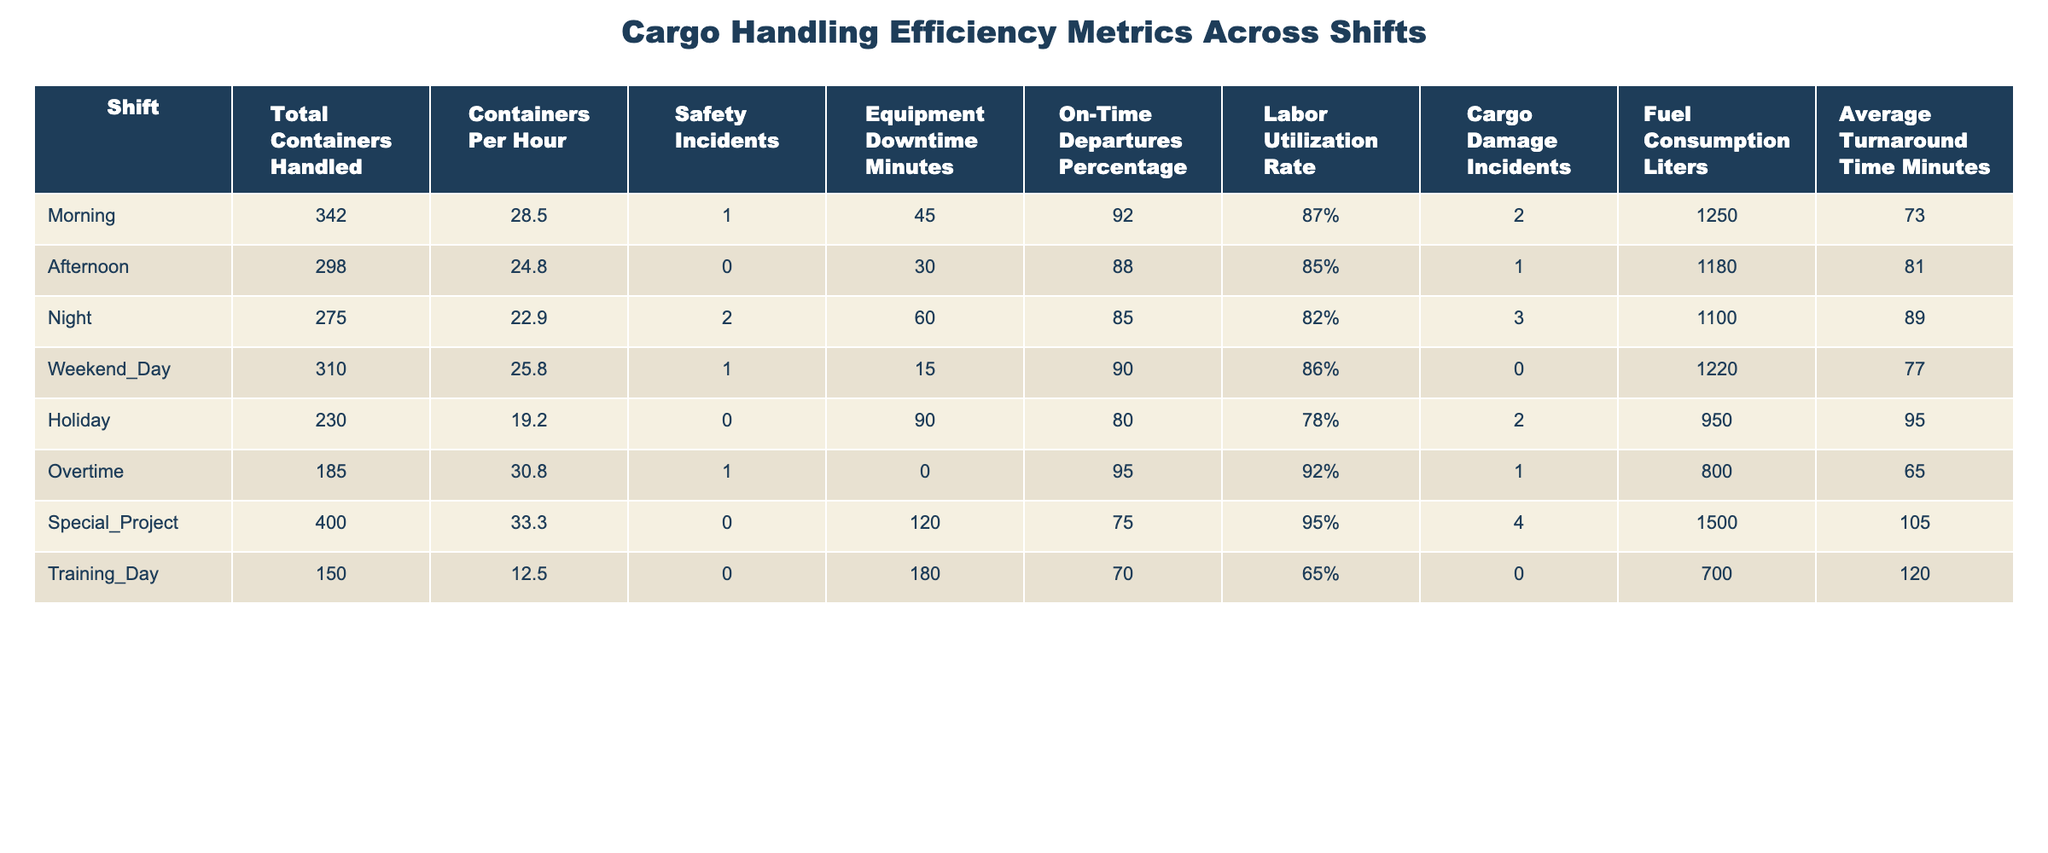What shift had the highest number of total containers handled? The total containers handled are as follows: Morning (342), Afternoon (298), Night (275), Weekend Day (310), Holiday (230), Overtime (185), Special Project (400), Training Day (150). The highest is 400, which corresponds to the Special Project shift.
Answer: Special Project What is the average containers per hour across all shifts? The containers per hour for each shift are: Morning (28.5), Afternoon (24.8), Night (22.9), Weekend Day (25.8), Holiday (19.2), Overtime (30.8), Special Project (33.3), Training Day (12.5). Adding these gives 28.5 + 24.8 + 22.9 + 25.8 + 19.2 + 30.8 + 33.3 + 12.5 =  197.8. Since there are 8 shifts, the average is 197.8 / 8 = 24.725.
Answer: 24.725 How many shifts had zero safety incidents? Referencing the data: there are 5 shifts listed as having 0 safety incidents: Afternoon, Holiday, Overtime, Special Project, and Training Day. Therefore, the total is 5 shifts.
Answer: 5 Which shift had the longest average turnaround time? The average turnaround times are: Morning (73), Afternoon (81), Night (89), Weekend Day (77), Holiday (95), Overtime (65), Special Project (105), and Training Day (120). The highest is 120, corresponding to the Training Day shift.
Answer: Training Day What percentage of on-time departures does the Night shift have compared to the Morning shift? The Night shift has 85% and the Morning shift has 92%. To find the percentage of Night departures to Morning, we calculate (85 / 92) * 100, which equals approximately 92.39%.
Answer: 92.39% Is the fuel consumption higher for shifts with fewer containers handled? The fuel consumption in liters for different shifts indicates a pattern where the lower handling (Training Day at 700) coincides with fewer containers (150). However, the Holiday shift also had low handling (230) while consuming less fuel (950). Hence, the pattern is not consistent. Thus, we conclude that there is no clear correlation evident.
Answer: No What can we infer about the relationship between safety incidents and labor utilization rate in the Night shift? In the Night shift, there is a total of 2 safety incidents and a labor utilization rate of 82%. Looking at the data for other shifts with safety incidents compared to their labor utilization rates may imply an inverse relationship might exist; as incidents rose, the utilization varied significantly (for example, the Morning shift with 1 incident maintains 87%).
Answer: Inconclusive Which shift had the least equipment downtime minutes? The downtime minutes are as follows: Morning (45), Afternoon (30), Night (60), Weekend Day (15), Holiday (90), Overtime (0), Special Project (120), and Training Day (180). The least amount of downtime is 0, found in the Overtime shift.
Answer: Overtime 